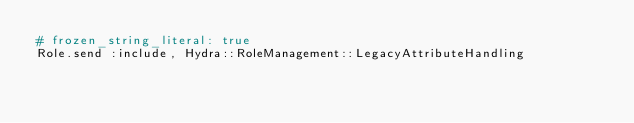<code> <loc_0><loc_0><loc_500><loc_500><_Ruby_># frozen_string_literal: true
Role.send :include, Hydra::RoleManagement::LegacyAttributeHandling
</code> 